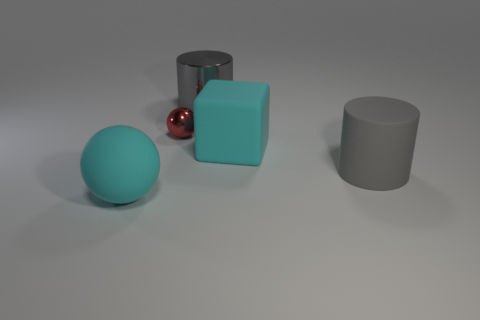What material do the objects in the image most likely resemble? The objects in the image appear to have a matte finish, similar to rubber or a frosted type of plastic, which suggests they're designed to mimic materials used in physical objects for a more realistic rendering or study. 